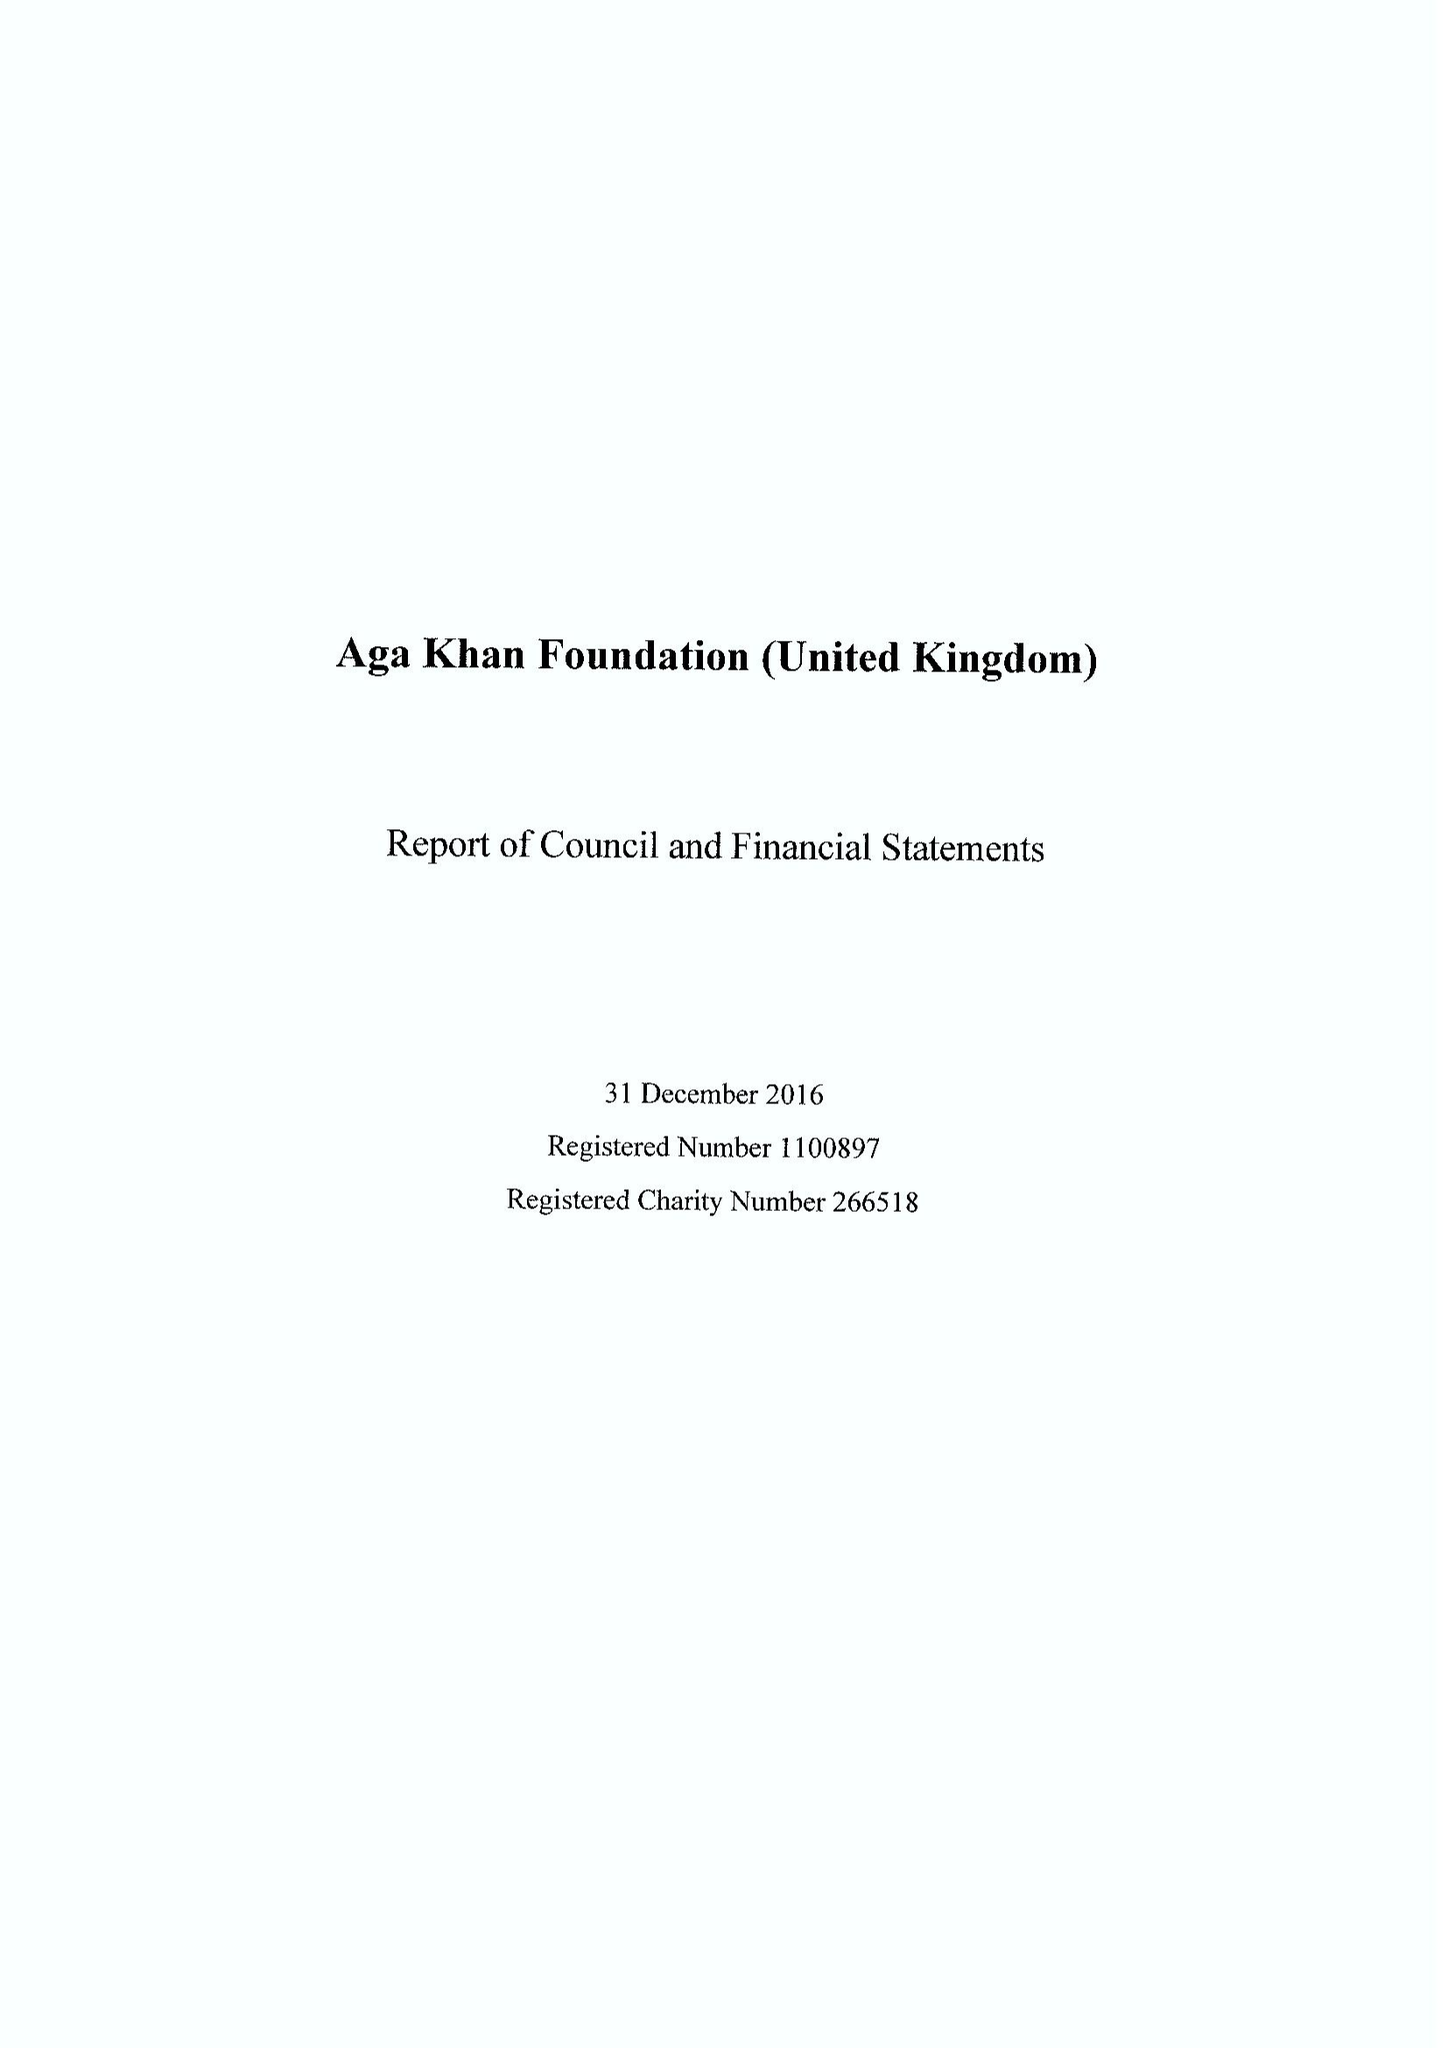What is the value for the report_date?
Answer the question using a single word or phrase. 2016-12-31 